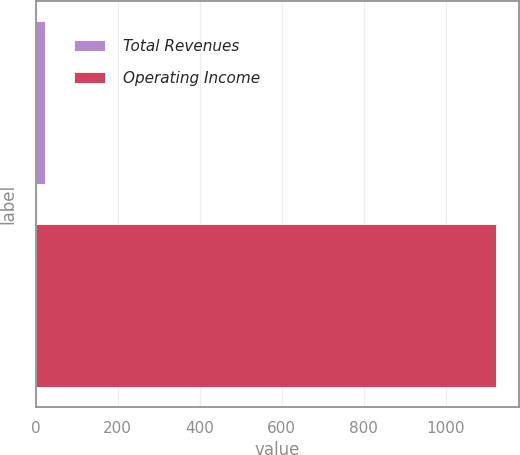Convert chart to OTSL. <chart><loc_0><loc_0><loc_500><loc_500><bar_chart><fcel>Total Revenues<fcel>Operating Income<nl><fcel>23<fcel>1122<nl></chart> 